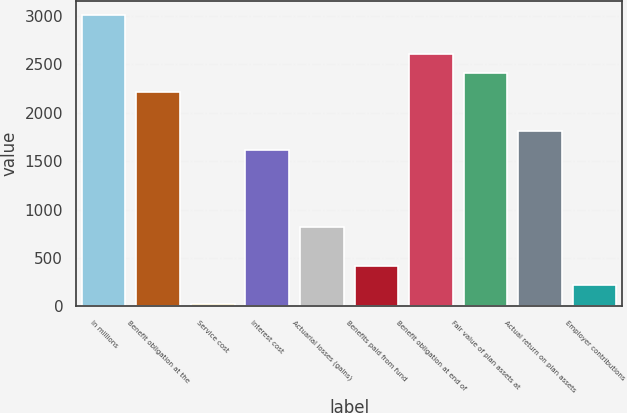<chart> <loc_0><loc_0><loc_500><loc_500><bar_chart><fcel>In millions<fcel>Benefit obligation at the<fcel>Service cost<fcel>Interest cost<fcel>Actuarial losses (gains)<fcel>Benefits paid from fund<fcel>Benefit obligation at end of<fcel>Fair value of plan assets at<fcel>Actual return on plan assets<fcel>Employer contributions<nl><fcel>3007.5<fcel>2211.1<fcel>21<fcel>1613.8<fcel>817.4<fcel>419.2<fcel>2609.3<fcel>2410.2<fcel>1812.9<fcel>220.1<nl></chart> 